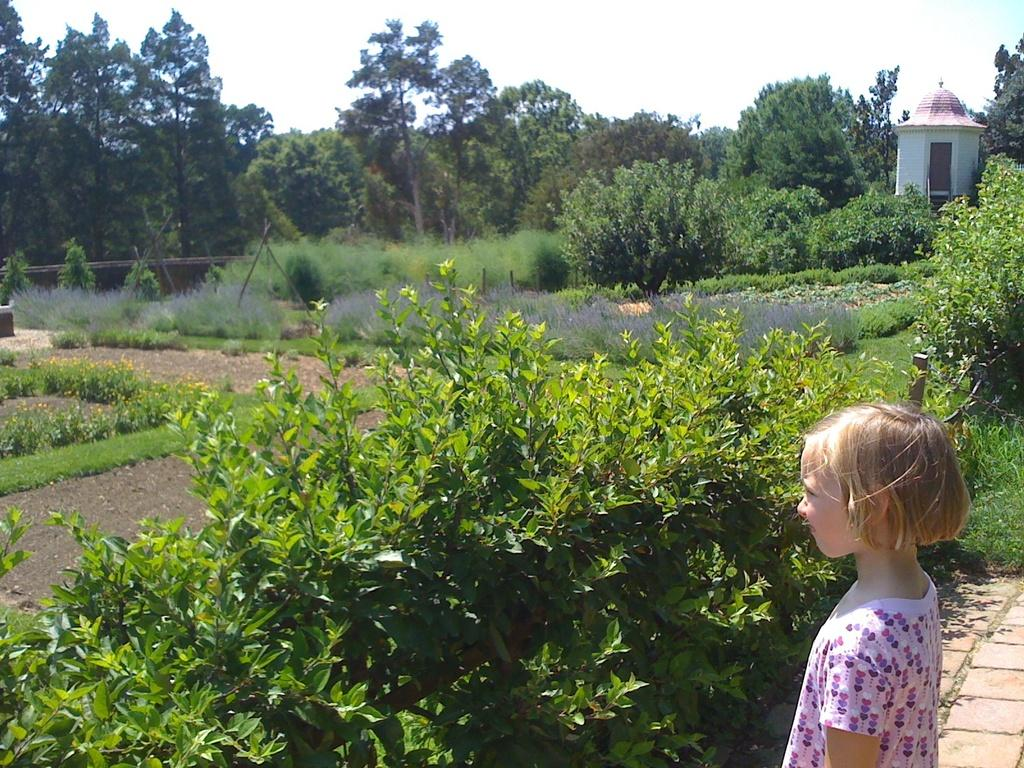Who is the main subject in the image? There is a girl in the image. What is the girl standing in front of? The girl is standing in front of plants. What can be seen in the background of the image? There is a room and trees visible in the background of the image. How does the girl capture the attention of the rainstorm in the image? There is no rainstorm present in the image, so the girl cannot capture its attention. 